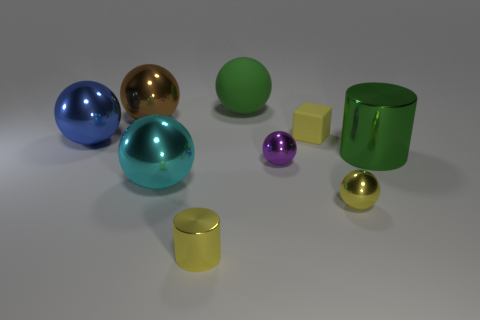Subtract all green spheres. How many spheres are left? 5 Add 1 tiny green blocks. How many objects exist? 10 Subtract all cyan spheres. How many spheres are left? 5 Subtract all cylinders. How many objects are left? 7 Subtract 0 red spheres. How many objects are left? 9 Subtract all purple cubes. Subtract all red cylinders. How many cubes are left? 1 Subtract all large cyan balls. Subtract all green balls. How many objects are left? 7 Add 3 brown things. How many brown things are left? 4 Add 8 big gray cylinders. How many big gray cylinders exist? 8 